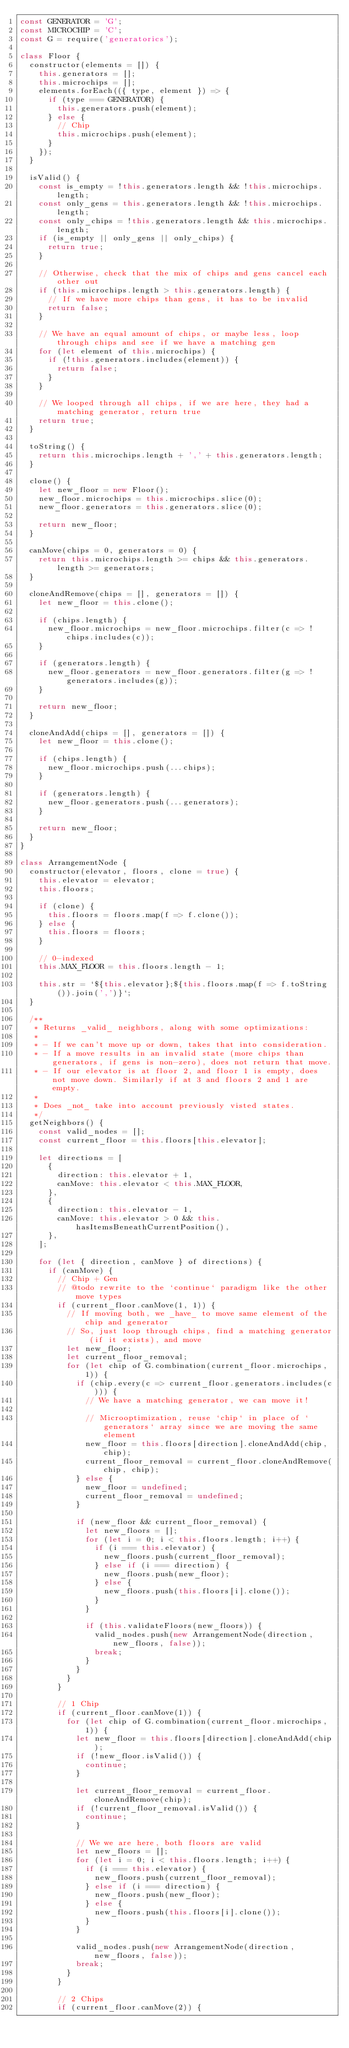Convert code to text. <code><loc_0><loc_0><loc_500><loc_500><_JavaScript_>const GENERATOR = 'G';
const MICROCHIP = 'C';
const G = require('generatorics');

class Floor {
	constructor(elements = []) {
		this.generators = [];
		this.microchips = [];
		elements.forEach(({ type, element }) => {
			if (type === GENERATOR) {
				this.generators.push(element);
			} else {
				// Chip
				this.microchips.push(element);
			}
		});
	}

	isValid() {
		const is_empty = !this.generators.length && !this.microchips.length;
		const only_gens = this.generators.length && !this.microchips.length;
		const only_chips = !this.generators.length && this.microchips.length;
		if (is_empty || only_gens || only_chips) {
			return true;
		}

		// Otherwise, check that the mix of chips and gens cancel each other out
		if (this.microchips.length > this.generators.length) {
			// If we have more chips than gens, it has to be invalid
			return false;
		}

		// We have an equal amount of chips, or maybe less, loop through chips and see if we have a matching gen
		for (let element of this.microchips) {
			if (!this.generators.includes(element)) {
				return false;
			}
		}

		// We looped through all chips, if we are here, they had a matching generator, return true
		return true;
	}

	toString() {
		return this.microchips.length + ',' + this.generators.length;
	}

	clone() {
		let new_floor = new Floor();
		new_floor.microchips = this.microchips.slice(0);
		new_floor.generators = this.generators.slice(0);

		return new_floor;
	}

	canMove(chips = 0, generators = 0) {
		return this.microchips.length >= chips && this.generators.length >= generators;
	}

	cloneAndRemove(chips = [], generators = []) {
		let new_floor = this.clone();

		if (chips.length) {
			new_floor.microchips = new_floor.microchips.filter(c => !chips.includes(c));
		}

		if (generators.length) {
			new_floor.generators = new_floor.generators.filter(g => !generators.includes(g));
		}

		return new_floor;
	}

	cloneAndAdd(chips = [], generators = []) {
		let new_floor = this.clone();

		if (chips.length) {
			new_floor.microchips.push(...chips);
		}

		if (generators.length) {
			new_floor.generators.push(...generators);
		}

		return new_floor;
	}
}

class ArrangementNode {
	constructor(elevator, floors, clone = true) {
		this.elevator = elevator;
		this.floors;

		if (clone) {
			this.floors = floors.map(f => f.clone());
		} else {
			this.floors = floors;
		}

		// 0-indexed
		this.MAX_FLOOR = this.floors.length - 1;

		this.str = `${this.elevator};${this.floors.map(f => f.toString()).join(',')}`;
	}

	/**
	 * Returns _valid_ neighbors, along with some optimizations:
	 *
	 * - If we can't move up or down, takes that into consideration.
	 * - If a move results in an invalid state (more chips than generators, if gens is non-zero), does not return that move.
	 * - If our elevator is at floor 2, and floor 1 is empty, does not move down. Similarly if at 3 and floors 2 and 1 are empty.
	 *
	 * Does _not_ take into account previously visted states.
	 */
	getNeighbors() {
		const valid_nodes = [];
		const current_floor = this.floors[this.elevator];

		let directions = [
			{
				direction: this.elevator + 1,
				canMove: this.elevator < this.MAX_FLOOR,
			},
			{
				direction: this.elevator - 1,
				canMove: this.elevator > 0 && this.hasItemsBeneathCurrentPosition(),
			},
		];

		for (let { direction, canMove } of directions) {
			if (canMove) {
				// Chip + Gen
				// @todo rewrite to the `continue` paradigm like the other move types
				if (current_floor.canMove(1, 1)) {
					// If moving both, we _have_ to move same element of the chip and generator
					// So, just loop through chips, find a matching generator (if it exists), and move
					let new_floor;
					let current_floor_removal;
					for (let chip of G.combination(current_floor.microchips, 1)) {
						if (chip.every(c => current_floor.generators.includes(c))) {
							// We have a matching generator, we can move it!

							// Microoptimization, reuse `chip` in place of `generators` array since we are moving the same element
							new_floor = this.floors[direction].cloneAndAdd(chip, chip);
							current_floor_removal = current_floor.cloneAndRemove(chip, chip);
						} else {
							new_floor = undefined;
							current_floor_removal = undefined;
						}

						if (new_floor && current_floor_removal) {
							let new_floors = [];
							for (let i = 0; i < this.floors.length; i++) {
								if (i === this.elevator) {
									new_floors.push(current_floor_removal);
								} else if (i === direction) {
									new_floors.push(new_floor);
								} else {
									new_floors.push(this.floors[i].clone());
								}
							}

							if (this.validateFloors(new_floors)) {
								valid_nodes.push(new ArrangementNode(direction, new_floors, false));
								break;
							}
						}
					}
				}

				// 1 Chip
				if (current_floor.canMove(1)) {
					for (let chip of G.combination(current_floor.microchips, 1)) {
						let new_floor = this.floors[direction].cloneAndAdd(chip);
						if (!new_floor.isValid()) {
							continue;
						}

						let current_floor_removal = current_floor.cloneAndRemove(chip);
						if (!current_floor_removal.isValid()) {
							continue;
						}

						// We we are here, both floors are valid
						let new_floors = [];
						for (let i = 0; i < this.floors.length; i++) {
							if (i === this.elevator) {
								new_floors.push(current_floor_removal);
							} else if (i === direction) {
								new_floors.push(new_floor);
							} else {
								new_floors.push(this.floors[i].clone());
							}
						}

						valid_nodes.push(new ArrangementNode(direction, new_floors, false));
						break;
					}
				}

				// 2 Chips
				if (current_floor.canMove(2)) {</code> 